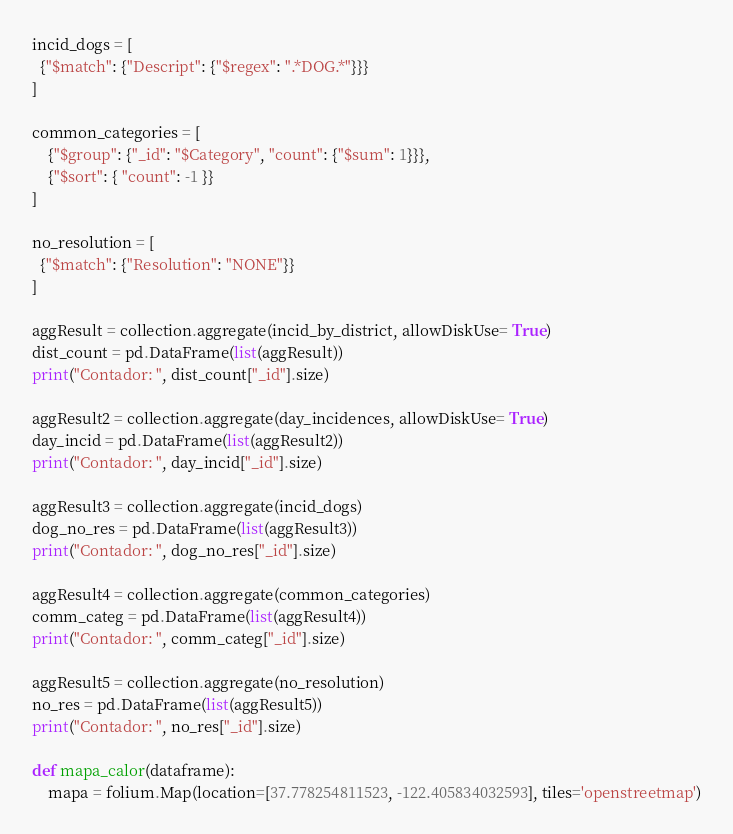<code> <loc_0><loc_0><loc_500><loc_500><_Python_>
incid_dogs = [
  {"$match": {"Descript": {"$regex": ".*DOG.*"}}}
]

common_categories = [
    {"$group": {"_id": "$Category", "count": {"$sum": 1}}},
    {"$sort": { "count": -1 }}
]

no_resolution = [
  {"$match": {"Resolution": "NONE"}}
]

aggResult = collection.aggregate(incid_by_district, allowDiskUse= True)
dist_count = pd.DataFrame(list(aggResult))
print("Contador: ", dist_count["_id"].size)

aggResult2 = collection.aggregate(day_incidences, allowDiskUse= True)
day_incid = pd.DataFrame(list(aggResult2))
print("Contador: ", day_incid["_id"].size)

aggResult3 = collection.aggregate(incid_dogs)
dog_no_res = pd.DataFrame(list(aggResult3))
print("Contador: ", dog_no_res["_id"].size)

aggResult4 = collection.aggregate(common_categories)
comm_categ = pd.DataFrame(list(aggResult4))
print("Contador: ", comm_categ["_id"].size)

aggResult5 = collection.aggregate(no_resolution)
no_res = pd.DataFrame(list(aggResult5))
print("Contador: ", no_res["_id"].size)

def mapa_calor(dataframe):
    mapa = folium.Map(location=[37.778254811523, -122.405834032593], tiles='openstreetmap')</code> 